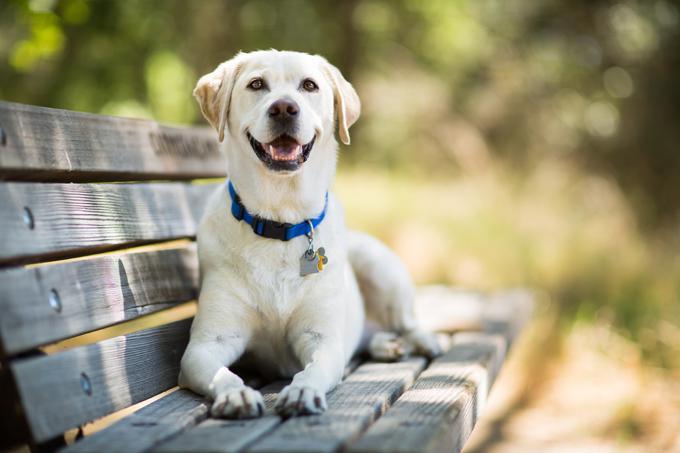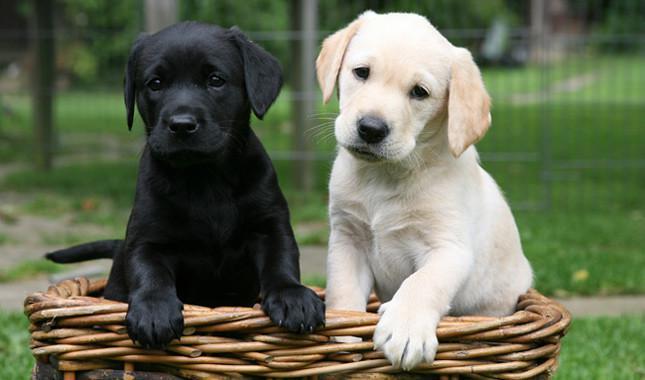The first image is the image on the left, the second image is the image on the right. Considering the images on both sides, is "An image shows a puppy with tongue showing and something in its mouth." valid? Answer yes or no. No. The first image is the image on the left, the second image is the image on the right. Given the left and right images, does the statement "The dog in the grass in the image on the left has something to play with." hold true? Answer yes or no. No. 